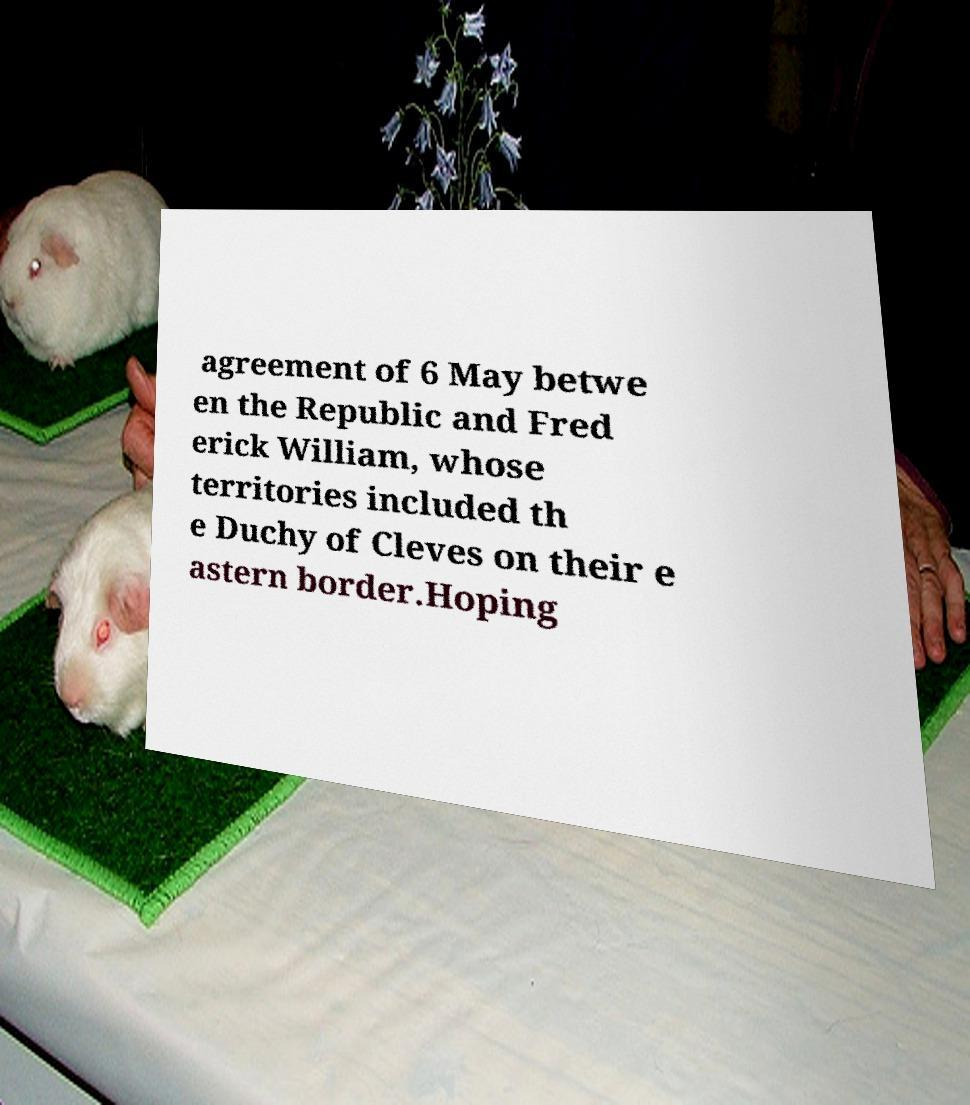What messages or text are displayed in this image? I need them in a readable, typed format. agreement of 6 May betwe en the Republic and Fred erick William, whose territories included th e Duchy of Cleves on their e astern border.Hoping 